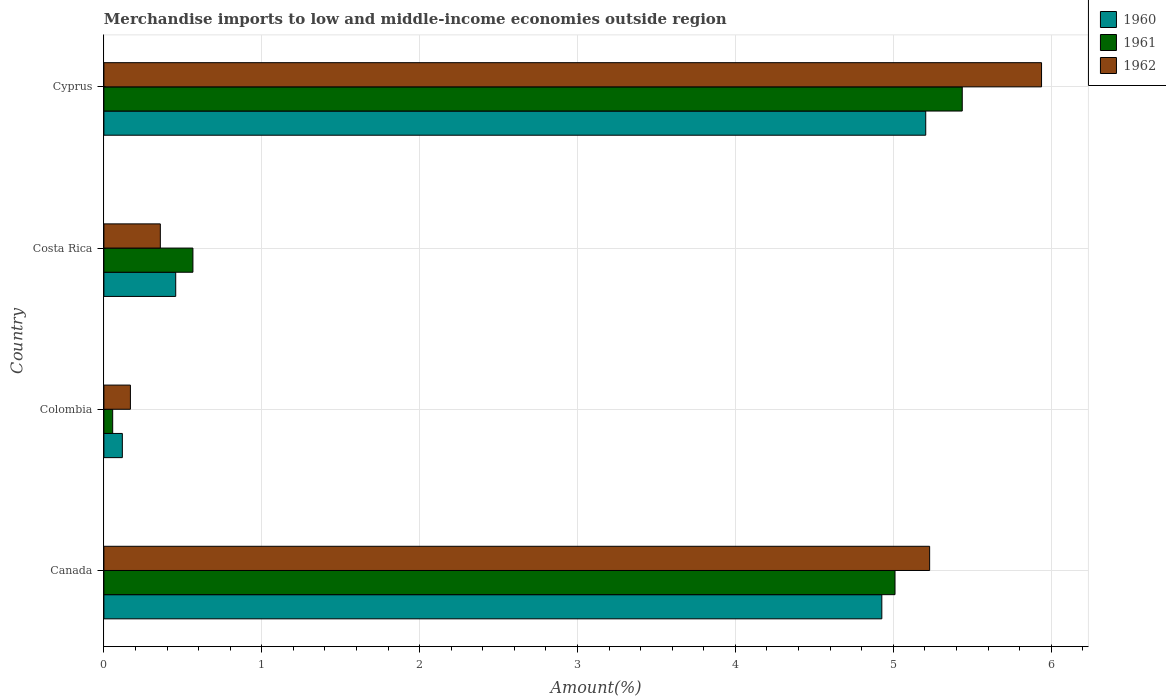How many groups of bars are there?
Ensure brevity in your answer.  4. What is the percentage of amount earned from merchandise imports in 1962 in Cyprus?
Provide a short and direct response. 5.94. Across all countries, what is the maximum percentage of amount earned from merchandise imports in 1960?
Offer a terse response. 5.21. Across all countries, what is the minimum percentage of amount earned from merchandise imports in 1962?
Ensure brevity in your answer.  0.17. In which country was the percentage of amount earned from merchandise imports in 1961 maximum?
Provide a short and direct response. Cyprus. In which country was the percentage of amount earned from merchandise imports in 1960 minimum?
Ensure brevity in your answer.  Colombia. What is the total percentage of amount earned from merchandise imports in 1961 in the graph?
Your answer should be compact. 11.07. What is the difference between the percentage of amount earned from merchandise imports in 1962 in Colombia and that in Cyprus?
Your response must be concise. -5.77. What is the difference between the percentage of amount earned from merchandise imports in 1962 in Cyprus and the percentage of amount earned from merchandise imports in 1960 in Colombia?
Offer a terse response. 5.82. What is the average percentage of amount earned from merchandise imports in 1961 per country?
Give a very brief answer. 2.77. What is the difference between the percentage of amount earned from merchandise imports in 1961 and percentage of amount earned from merchandise imports in 1962 in Cyprus?
Provide a succinct answer. -0.5. What is the ratio of the percentage of amount earned from merchandise imports in 1960 in Canada to that in Costa Rica?
Your answer should be very brief. 10.83. Is the percentage of amount earned from merchandise imports in 1962 in Colombia less than that in Costa Rica?
Your answer should be compact. Yes. What is the difference between the highest and the second highest percentage of amount earned from merchandise imports in 1962?
Give a very brief answer. 0.71. What is the difference between the highest and the lowest percentage of amount earned from merchandise imports in 1962?
Offer a terse response. 5.77. In how many countries, is the percentage of amount earned from merchandise imports in 1961 greater than the average percentage of amount earned from merchandise imports in 1961 taken over all countries?
Provide a short and direct response. 2. Is the sum of the percentage of amount earned from merchandise imports in 1960 in Colombia and Costa Rica greater than the maximum percentage of amount earned from merchandise imports in 1961 across all countries?
Provide a succinct answer. No. Are all the bars in the graph horizontal?
Offer a terse response. Yes. Are the values on the major ticks of X-axis written in scientific E-notation?
Offer a very short reply. No. Does the graph contain grids?
Ensure brevity in your answer.  Yes. Where does the legend appear in the graph?
Ensure brevity in your answer.  Top right. What is the title of the graph?
Offer a terse response. Merchandise imports to low and middle-income economies outside region. Does "1994" appear as one of the legend labels in the graph?
Your answer should be very brief. No. What is the label or title of the X-axis?
Your answer should be very brief. Amount(%). What is the Amount(%) in 1960 in Canada?
Ensure brevity in your answer.  4.93. What is the Amount(%) of 1961 in Canada?
Your answer should be very brief. 5.01. What is the Amount(%) in 1962 in Canada?
Your answer should be very brief. 5.23. What is the Amount(%) in 1960 in Colombia?
Provide a short and direct response. 0.12. What is the Amount(%) of 1961 in Colombia?
Ensure brevity in your answer.  0.06. What is the Amount(%) of 1962 in Colombia?
Ensure brevity in your answer.  0.17. What is the Amount(%) in 1960 in Costa Rica?
Give a very brief answer. 0.45. What is the Amount(%) of 1961 in Costa Rica?
Keep it short and to the point. 0.56. What is the Amount(%) in 1962 in Costa Rica?
Give a very brief answer. 0.36. What is the Amount(%) in 1960 in Cyprus?
Make the answer very short. 5.21. What is the Amount(%) of 1961 in Cyprus?
Ensure brevity in your answer.  5.44. What is the Amount(%) in 1962 in Cyprus?
Offer a terse response. 5.94. Across all countries, what is the maximum Amount(%) in 1960?
Offer a terse response. 5.21. Across all countries, what is the maximum Amount(%) of 1961?
Your answer should be very brief. 5.44. Across all countries, what is the maximum Amount(%) in 1962?
Offer a terse response. 5.94. Across all countries, what is the minimum Amount(%) of 1960?
Provide a succinct answer. 0.12. Across all countries, what is the minimum Amount(%) of 1961?
Your answer should be compact. 0.06. Across all countries, what is the minimum Amount(%) in 1962?
Ensure brevity in your answer.  0.17. What is the total Amount(%) in 1960 in the graph?
Give a very brief answer. 10.7. What is the total Amount(%) of 1961 in the graph?
Provide a succinct answer. 11.07. What is the total Amount(%) of 1962 in the graph?
Your answer should be very brief. 11.69. What is the difference between the Amount(%) of 1960 in Canada and that in Colombia?
Your response must be concise. 4.81. What is the difference between the Amount(%) in 1961 in Canada and that in Colombia?
Your response must be concise. 4.96. What is the difference between the Amount(%) in 1962 in Canada and that in Colombia?
Provide a succinct answer. 5.06. What is the difference between the Amount(%) of 1960 in Canada and that in Costa Rica?
Provide a succinct answer. 4.47. What is the difference between the Amount(%) of 1961 in Canada and that in Costa Rica?
Provide a short and direct response. 4.45. What is the difference between the Amount(%) of 1962 in Canada and that in Costa Rica?
Keep it short and to the point. 4.87. What is the difference between the Amount(%) in 1960 in Canada and that in Cyprus?
Your answer should be very brief. -0.28. What is the difference between the Amount(%) in 1961 in Canada and that in Cyprus?
Your answer should be compact. -0.43. What is the difference between the Amount(%) in 1962 in Canada and that in Cyprus?
Make the answer very short. -0.71. What is the difference between the Amount(%) in 1960 in Colombia and that in Costa Rica?
Ensure brevity in your answer.  -0.34. What is the difference between the Amount(%) in 1961 in Colombia and that in Costa Rica?
Give a very brief answer. -0.51. What is the difference between the Amount(%) in 1962 in Colombia and that in Costa Rica?
Keep it short and to the point. -0.19. What is the difference between the Amount(%) in 1960 in Colombia and that in Cyprus?
Provide a short and direct response. -5.09. What is the difference between the Amount(%) in 1961 in Colombia and that in Cyprus?
Your answer should be compact. -5.38. What is the difference between the Amount(%) of 1962 in Colombia and that in Cyprus?
Your answer should be compact. -5.77. What is the difference between the Amount(%) of 1960 in Costa Rica and that in Cyprus?
Provide a short and direct response. -4.75. What is the difference between the Amount(%) in 1961 in Costa Rica and that in Cyprus?
Keep it short and to the point. -4.87. What is the difference between the Amount(%) in 1962 in Costa Rica and that in Cyprus?
Your answer should be very brief. -5.58. What is the difference between the Amount(%) of 1960 in Canada and the Amount(%) of 1961 in Colombia?
Ensure brevity in your answer.  4.87. What is the difference between the Amount(%) in 1960 in Canada and the Amount(%) in 1962 in Colombia?
Ensure brevity in your answer.  4.76. What is the difference between the Amount(%) in 1961 in Canada and the Amount(%) in 1962 in Colombia?
Your response must be concise. 4.84. What is the difference between the Amount(%) in 1960 in Canada and the Amount(%) in 1961 in Costa Rica?
Make the answer very short. 4.36. What is the difference between the Amount(%) of 1960 in Canada and the Amount(%) of 1962 in Costa Rica?
Your response must be concise. 4.57. What is the difference between the Amount(%) in 1961 in Canada and the Amount(%) in 1962 in Costa Rica?
Make the answer very short. 4.65. What is the difference between the Amount(%) in 1960 in Canada and the Amount(%) in 1961 in Cyprus?
Ensure brevity in your answer.  -0.51. What is the difference between the Amount(%) in 1960 in Canada and the Amount(%) in 1962 in Cyprus?
Give a very brief answer. -1.01. What is the difference between the Amount(%) in 1961 in Canada and the Amount(%) in 1962 in Cyprus?
Your response must be concise. -0.93. What is the difference between the Amount(%) of 1960 in Colombia and the Amount(%) of 1961 in Costa Rica?
Offer a very short reply. -0.45. What is the difference between the Amount(%) in 1960 in Colombia and the Amount(%) in 1962 in Costa Rica?
Your response must be concise. -0.24. What is the difference between the Amount(%) in 1961 in Colombia and the Amount(%) in 1962 in Costa Rica?
Your response must be concise. -0.3. What is the difference between the Amount(%) of 1960 in Colombia and the Amount(%) of 1961 in Cyprus?
Ensure brevity in your answer.  -5.32. What is the difference between the Amount(%) in 1960 in Colombia and the Amount(%) in 1962 in Cyprus?
Provide a succinct answer. -5.82. What is the difference between the Amount(%) of 1961 in Colombia and the Amount(%) of 1962 in Cyprus?
Provide a succinct answer. -5.88. What is the difference between the Amount(%) of 1960 in Costa Rica and the Amount(%) of 1961 in Cyprus?
Provide a succinct answer. -4.98. What is the difference between the Amount(%) of 1960 in Costa Rica and the Amount(%) of 1962 in Cyprus?
Provide a short and direct response. -5.48. What is the difference between the Amount(%) of 1961 in Costa Rica and the Amount(%) of 1962 in Cyprus?
Provide a short and direct response. -5.38. What is the average Amount(%) in 1960 per country?
Make the answer very short. 2.68. What is the average Amount(%) of 1961 per country?
Give a very brief answer. 2.77. What is the average Amount(%) of 1962 per country?
Offer a terse response. 2.92. What is the difference between the Amount(%) of 1960 and Amount(%) of 1961 in Canada?
Offer a terse response. -0.08. What is the difference between the Amount(%) in 1960 and Amount(%) in 1962 in Canada?
Give a very brief answer. -0.3. What is the difference between the Amount(%) of 1961 and Amount(%) of 1962 in Canada?
Your answer should be compact. -0.22. What is the difference between the Amount(%) of 1960 and Amount(%) of 1961 in Colombia?
Provide a short and direct response. 0.06. What is the difference between the Amount(%) of 1960 and Amount(%) of 1962 in Colombia?
Offer a very short reply. -0.05. What is the difference between the Amount(%) in 1961 and Amount(%) in 1962 in Colombia?
Ensure brevity in your answer.  -0.11. What is the difference between the Amount(%) in 1960 and Amount(%) in 1961 in Costa Rica?
Ensure brevity in your answer.  -0.11. What is the difference between the Amount(%) in 1960 and Amount(%) in 1962 in Costa Rica?
Your response must be concise. 0.1. What is the difference between the Amount(%) in 1961 and Amount(%) in 1962 in Costa Rica?
Offer a terse response. 0.21. What is the difference between the Amount(%) of 1960 and Amount(%) of 1961 in Cyprus?
Your answer should be compact. -0.23. What is the difference between the Amount(%) in 1960 and Amount(%) in 1962 in Cyprus?
Offer a very short reply. -0.73. What is the difference between the Amount(%) in 1961 and Amount(%) in 1962 in Cyprus?
Your answer should be very brief. -0.5. What is the ratio of the Amount(%) of 1960 in Canada to that in Colombia?
Your answer should be very brief. 42.16. What is the ratio of the Amount(%) in 1961 in Canada to that in Colombia?
Provide a succinct answer. 89.96. What is the ratio of the Amount(%) in 1962 in Canada to that in Colombia?
Offer a terse response. 31.15. What is the ratio of the Amount(%) in 1960 in Canada to that in Costa Rica?
Give a very brief answer. 10.83. What is the ratio of the Amount(%) in 1961 in Canada to that in Costa Rica?
Your response must be concise. 8.89. What is the ratio of the Amount(%) in 1962 in Canada to that in Costa Rica?
Your answer should be compact. 14.63. What is the ratio of the Amount(%) in 1960 in Canada to that in Cyprus?
Provide a short and direct response. 0.95. What is the ratio of the Amount(%) of 1961 in Canada to that in Cyprus?
Give a very brief answer. 0.92. What is the ratio of the Amount(%) of 1962 in Canada to that in Cyprus?
Provide a short and direct response. 0.88. What is the ratio of the Amount(%) of 1960 in Colombia to that in Costa Rica?
Your answer should be compact. 0.26. What is the ratio of the Amount(%) of 1961 in Colombia to that in Costa Rica?
Your answer should be compact. 0.1. What is the ratio of the Amount(%) of 1962 in Colombia to that in Costa Rica?
Your answer should be very brief. 0.47. What is the ratio of the Amount(%) of 1960 in Colombia to that in Cyprus?
Provide a succinct answer. 0.02. What is the ratio of the Amount(%) in 1961 in Colombia to that in Cyprus?
Your response must be concise. 0.01. What is the ratio of the Amount(%) in 1962 in Colombia to that in Cyprus?
Ensure brevity in your answer.  0.03. What is the ratio of the Amount(%) in 1960 in Costa Rica to that in Cyprus?
Give a very brief answer. 0.09. What is the ratio of the Amount(%) of 1961 in Costa Rica to that in Cyprus?
Offer a terse response. 0.1. What is the ratio of the Amount(%) of 1962 in Costa Rica to that in Cyprus?
Your answer should be very brief. 0.06. What is the difference between the highest and the second highest Amount(%) in 1960?
Offer a terse response. 0.28. What is the difference between the highest and the second highest Amount(%) of 1961?
Provide a succinct answer. 0.43. What is the difference between the highest and the second highest Amount(%) of 1962?
Your answer should be very brief. 0.71. What is the difference between the highest and the lowest Amount(%) of 1960?
Your answer should be compact. 5.09. What is the difference between the highest and the lowest Amount(%) in 1961?
Provide a short and direct response. 5.38. What is the difference between the highest and the lowest Amount(%) in 1962?
Make the answer very short. 5.77. 